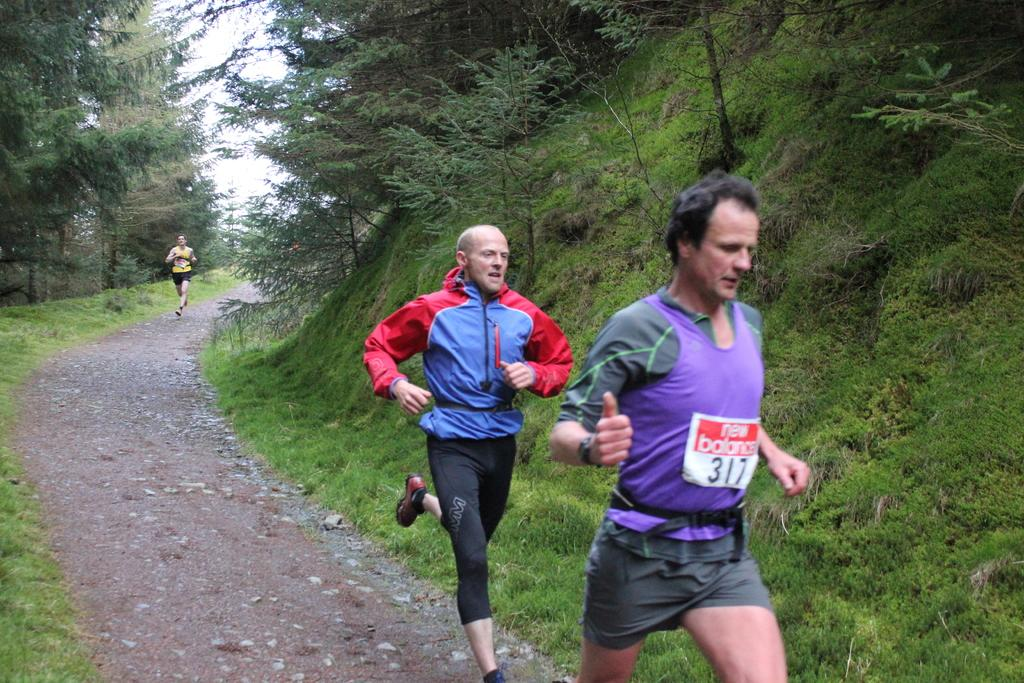What are the three persons in the image doing? The three persons in the image are running. What can be seen in the background of the image? There are trees visible in the image. What type of ground is present on either side of the persons? There is a greenery ground on either side of the persons. What type of art can be seen hanging from the trees in the image? There is no art visible hanging from the trees in the image; only trees are present. Can you tell me how many giraffes are running alongside the persons in the image? There are no giraffes present in the image; only the three persons are running. 